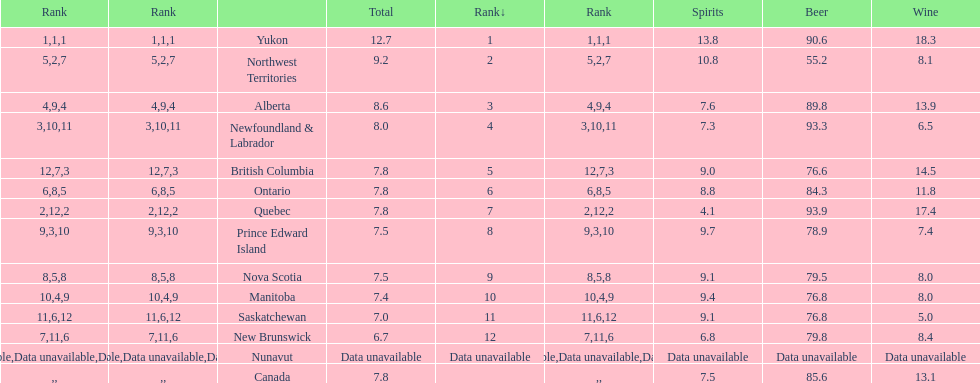Who drank more beer, quebec or northwest territories? Quebec. Could you help me parse every detail presented in this table? {'header': ['Rank', 'Rank', '', 'Total', 'Rank↓', 'Rank', 'Spirits', 'Beer', 'Wine'], 'rows': [['1', '1', 'Yukon', '12.7', '1', '1', '13.8', '90.6', '18.3'], ['5', '2', 'Northwest Territories', '9.2', '2', '7', '10.8', '55.2', '8.1'], ['4', '9', 'Alberta', '8.6', '3', '4', '7.6', '89.8', '13.9'], ['3', '10', 'Newfoundland & Labrador', '8.0', '4', '11', '7.3', '93.3', '6.5'], ['12', '7', 'British Columbia', '7.8', '5', '3', '9.0', '76.6', '14.5'], ['6', '8', 'Ontario', '7.8', '6', '5', '8.8', '84.3', '11.8'], ['2', '12', 'Quebec', '7.8', '7', '2', '4.1', '93.9', '17.4'], ['9', '3', 'Prince Edward Island', '7.5', '8', '10', '9.7', '78.9', '7.4'], ['8', '5', 'Nova Scotia', '7.5', '9', '8', '9.1', '79.5', '8.0'], ['10', '4', 'Manitoba', '7.4', '10', '9', '9.4', '76.8', '8.0'], ['11', '6', 'Saskatchewan', '7.0', '11', '12', '9.1', '76.8', '5.0'], ['7', '11', 'New Brunswick', '6.7', '12', '6', '6.8', '79.8', '8.4'], ['Data unavailable', 'Data unavailable', 'Nunavut', 'Data unavailable', 'Data unavailable', 'Data unavailable', 'Data unavailable', 'Data unavailable', 'Data unavailable'], ['', '', 'Canada', '7.8', '', '', '7.5', '85.6', '13.1']]} 